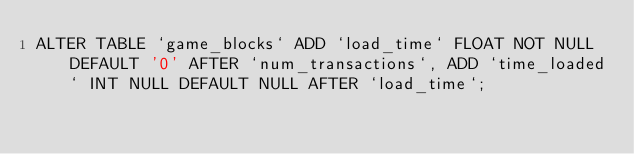Convert code to text. <code><loc_0><loc_0><loc_500><loc_500><_SQL_>ALTER TABLE `game_blocks` ADD `load_time` FLOAT NOT NULL DEFAULT '0' AFTER `num_transactions`, ADD `time_loaded` INT NULL DEFAULT NULL AFTER `load_time`;</code> 